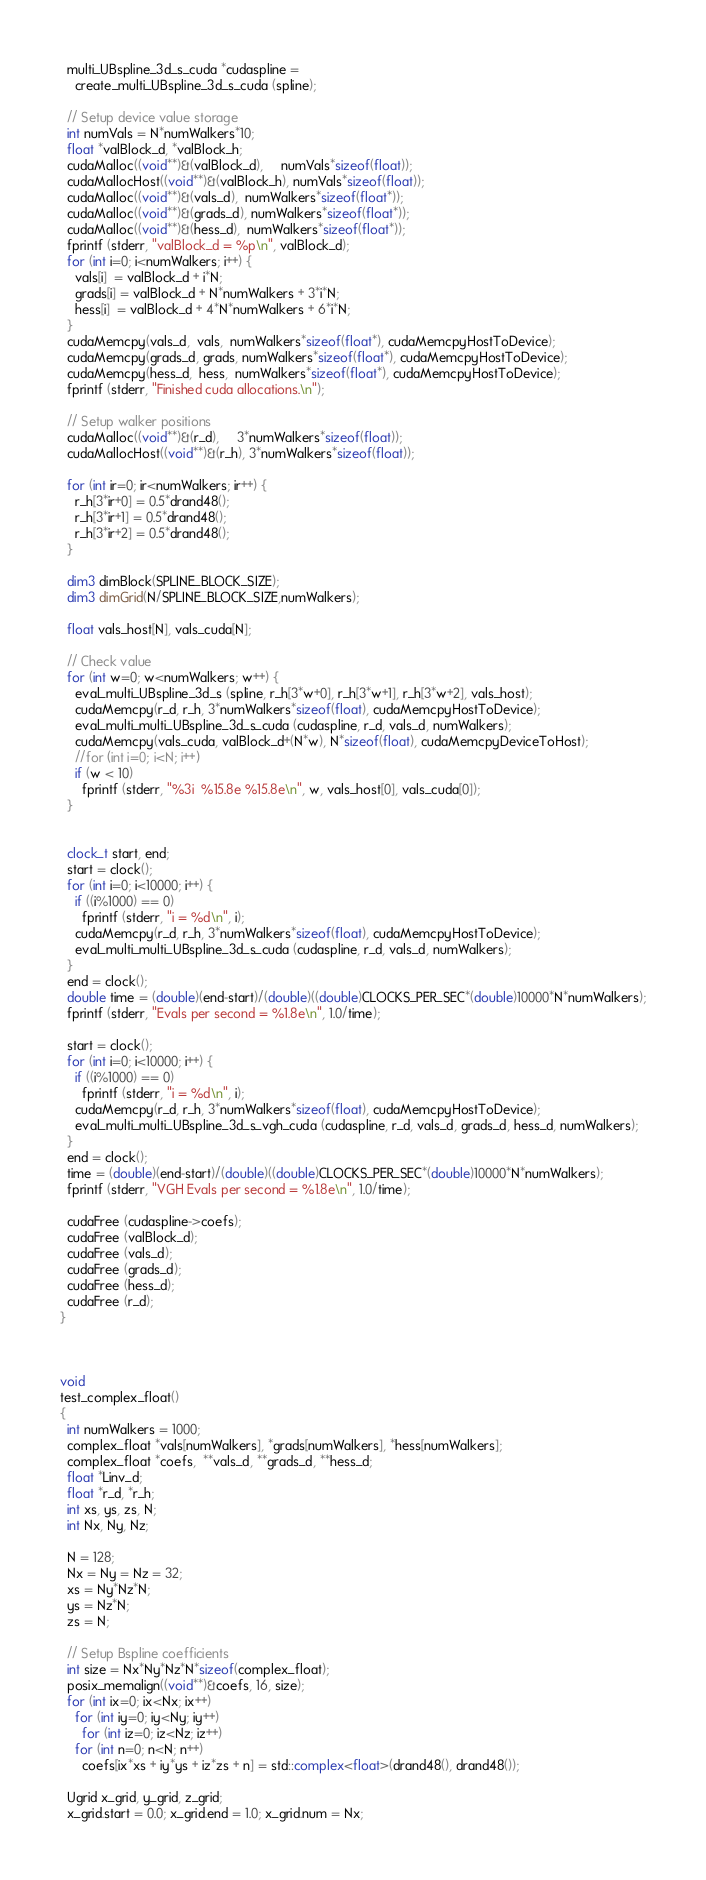<code> <loc_0><loc_0><loc_500><loc_500><_Cuda_>
  multi_UBspline_3d_s_cuda *cudaspline = 
    create_multi_UBspline_3d_s_cuda (spline);

  // Setup device value storage
  int numVals = N*numWalkers*10;
  float *valBlock_d, *valBlock_h;
  cudaMalloc((void**)&(valBlock_d),     numVals*sizeof(float));
  cudaMallocHost((void**)&(valBlock_h), numVals*sizeof(float));
  cudaMalloc((void**)&(vals_d),  numWalkers*sizeof(float*));
  cudaMalloc((void**)&(grads_d), numWalkers*sizeof(float*));
  cudaMalloc((void**)&(hess_d),  numWalkers*sizeof(float*));
  fprintf (stderr, "valBlock_d = %p\n", valBlock_d);
  for (int i=0; i<numWalkers; i++) {
    vals[i]  = valBlock_d + i*N;
    grads[i] = valBlock_d + N*numWalkers + 3*i*N;
    hess[i]  = valBlock_d + 4*N*numWalkers + 6*i*N;
  }
  cudaMemcpy(vals_d,  vals,  numWalkers*sizeof(float*), cudaMemcpyHostToDevice);
  cudaMemcpy(grads_d, grads, numWalkers*sizeof(float*), cudaMemcpyHostToDevice);
  cudaMemcpy(hess_d,  hess,  numWalkers*sizeof(float*), cudaMemcpyHostToDevice);
  fprintf (stderr, "Finished cuda allocations.\n");

  // Setup walker positions
  cudaMalloc((void**)&(r_d),     3*numWalkers*sizeof(float));
  cudaMallocHost((void**)&(r_h), 3*numWalkers*sizeof(float));

  for (int ir=0; ir<numWalkers; ir++) {
    r_h[3*ir+0] = 0.5*drand48();
    r_h[3*ir+1] = 0.5*drand48();
    r_h[3*ir+2] = 0.5*drand48();
  }

  dim3 dimBlock(SPLINE_BLOCK_SIZE);
  dim3 dimGrid(N/SPLINE_BLOCK_SIZE,numWalkers);
  
  float vals_host[N], vals_cuda[N];

  // Check value
  for (int w=0; w<numWalkers; w++) {
    eval_multi_UBspline_3d_s (spline, r_h[3*w+0], r_h[3*w+1], r_h[3*w+2], vals_host);
    cudaMemcpy(r_d, r_h, 3*numWalkers*sizeof(float), cudaMemcpyHostToDevice);
    eval_multi_multi_UBspline_3d_s_cuda (cudaspline, r_d, vals_d, numWalkers);
    cudaMemcpy(vals_cuda, valBlock_d+(N*w), N*sizeof(float), cudaMemcpyDeviceToHost);
    //for (int i=0; i<N; i++)
    if (w < 10)
      fprintf (stderr, "%3i  %15.8e %15.8e\n", w, vals_host[0], vals_cuda[0]);
  }


  clock_t start, end;
  start = clock();
  for (int i=0; i<10000; i++) {
    if ((i%1000) == 0) 
      fprintf (stderr, "i = %d\n", i);
    cudaMemcpy(r_d, r_h, 3*numWalkers*sizeof(float), cudaMemcpyHostToDevice);
    eval_multi_multi_UBspline_3d_s_cuda (cudaspline, r_d, vals_d, numWalkers);
  }
  end = clock();
  double time = (double)(end-start)/(double)((double)CLOCKS_PER_SEC*(double)10000*N*numWalkers);
  fprintf (stderr, "Evals per second = %1.8e\n", 1.0/time);

  start = clock();
  for (int i=0; i<10000; i++) {
    if ((i%1000) == 0) 
      fprintf (stderr, "i = %d\n", i);
    cudaMemcpy(r_d, r_h, 3*numWalkers*sizeof(float), cudaMemcpyHostToDevice);
    eval_multi_multi_UBspline_3d_s_vgh_cuda (cudaspline, r_d, vals_d, grads_d, hess_d, numWalkers);
  }
  end = clock();
  time = (double)(end-start)/(double)((double)CLOCKS_PER_SEC*(double)10000*N*numWalkers);
  fprintf (stderr, "VGH Evals per second = %1.8e\n", 1.0/time);
  
  cudaFree (cudaspline->coefs);
  cudaFree (valBlock_d);
  cudaFree (vals_d);
  cudaFree (grads_d);
  cudaFree (hess_d);
  cudaFree (r_d);
}



void
test_complex_float()
{
  int numWalkers = 1000;
  complex_float *vals[numWalkers], *grads[numWalkers], *hess[numWalkers];
  complex_float *coefs,  **vals_d, **grads_d, **hess_d;
  float *Linv_d;
  float *r_d, *r_h;
  int xs, ys, zs, N;
  int Nx, Ny, Nz;

  N = 128;
  Nx = Ny = Nz = 32;
  xs = Ny*Nz*N;
  ys = Nz*N;
  zs = N;

  // Setup Bspline coefficients
  int size = Nx*Ny*Nz*N*sizeof(complex_float);
  posix_memalign((void**)&coefs, 16, size);
  for (int ix=0; ix<Nx; ix++)
    for (int iy=0; iy<Ny; iy++)
      for (int iz=0; iz<Nz; iz++)
	for (int n=0; n<N; n++)
	  coefs[ix*xs + iy*ys + iz*zs + n] = std::complex<float>(drand48(), drand48());

  Ugrid x_grid, y_grid, z_grid;
  x_grid.start = 0.0; x_grid.end = 1.0; x_grid.num = Nx;</code> 